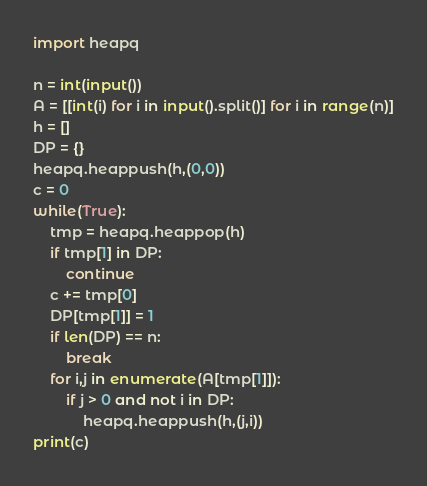Convert code to text. <code><loc_0><loc_0><loc_500><loc_500><_Python_>import heapq

n = int(input())
A = [[int(i) for i in input().split()] for i in range(n)]
h = []
DP = {}
heapq.heappush(h,(0,0))
c = 0
while(True):
    tmp = heapq.heappop(h)
    if tmp[1] in DP:
        continue
    c += tmp[0]
    DP[tmp[1]] = 1
    if len(DP) == n:
        break
    for i,j in enumerate(A[tmp[1]]):
        if j > 0 and not i in DP:
            heapq.heappush(h,(j,i))
print(c)
</code> 